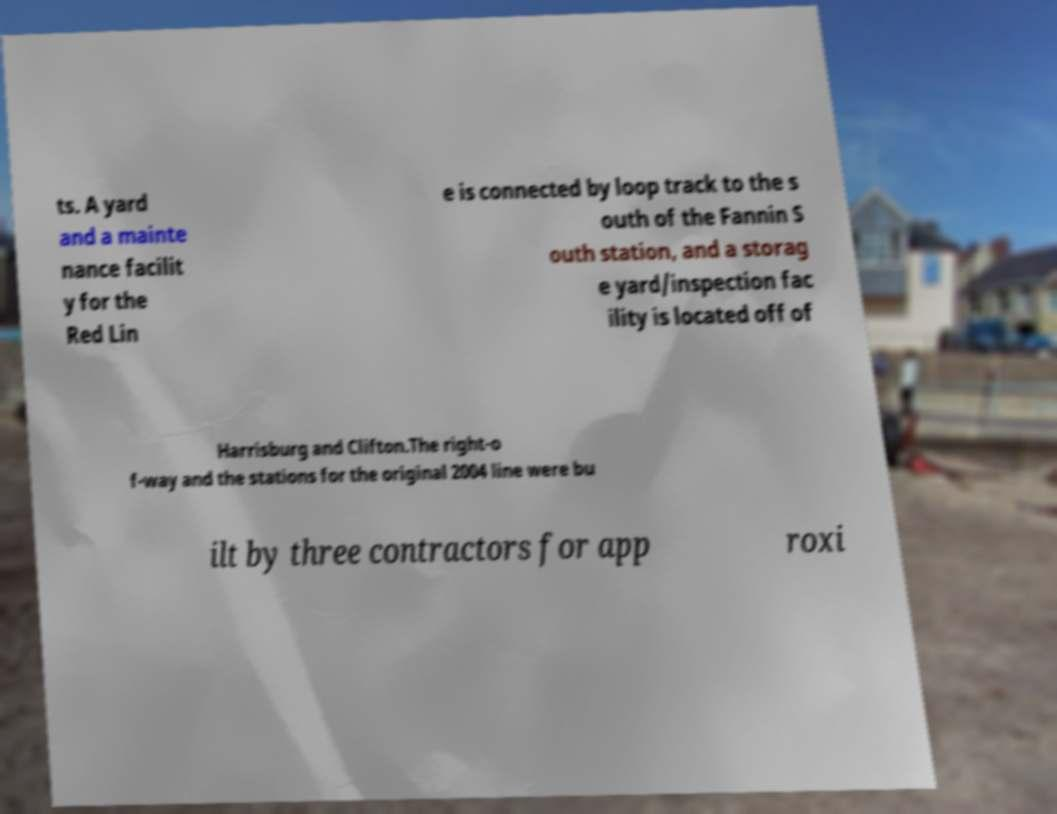Can you read and provide the text displayed in the image?This photo seems to have some interesting text. Can you extract and type it out for me? ts. A yard and a mainte nance facilit y for the Red Lin e is connected by loop track to the s outh of the Fannin S outh station, and a storag e yard/inspection fac ility is located off of Harrisburg and Clifton.The right-o f-way and the stations for the original 2004 line were bu ilt by three contractors for app roxi 